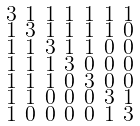<formula> <loc_0><loc_0><loc_500><loc_500>\begin{smallmatrix} 3 & 1 & 1 & 1 & 1 & 1 & 1 \\ 1 & 3 & 1 & 1 & 1 & 1 & 0 \\ 1 & 1 & 3 & 1 & 1 & 0 & 0 \\ 1 & 1 & 1 & 3 & 0 & 0 & 0 \\ 1 & 1 & 1 & 0 & 3 & 0 & 0 \\ 1 & 1 & 0 & 0 & 0 & 3 & 1 \\ 1 & 0 & 0 & 0 & 0 & 1 & 3 \end{smallmatrix}</formula> 